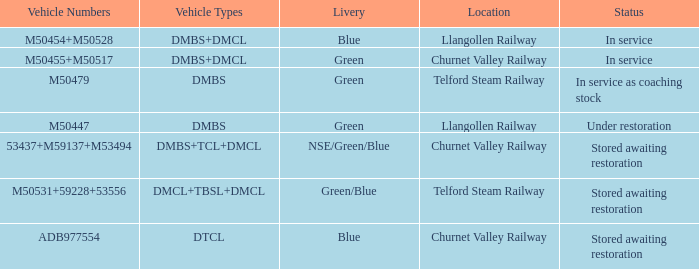Write the full table. {'header': ['Vehicle Numbers', 'Vehicle Types', 'Livery', 'Location', 'Status'], 'rows': [['M50454+M50528', 'DMBS+DMCL', 'Blue', 'Llangollen Railway', 'In service'], ['M50455+M50517', 'DMBS+DMCL', 'Green', 'Churnet Valley Railway', 'In service'], ['M50479', 'DMBS', 'Green', 'Telford Steam Railway', 'In service as coaching stock'], ['M50447', 'DMBS', 'Green', 'Llangollen Railway', 'Under restoration'], ['53437+M59137+M53494', 'DMBS+TCL+DMCL', 'NSE/Green/Blue', 'Churnet Valley Railway', 'Stored awaiting restoration'], ['M50531+59228+53556', 'DMCL+TBSL+DMCL', 'Green/Blue', 'Telford Steam Railway', 'Stored awaiting restoration'], ['ADB977554', 'DTCL', 'Blue', 'Churnet Valley Railway', 'Stored awaiting restoration']]} What status is the vehicle types of dmbs+tcl+dmcl? Stored awaiting restoration. 